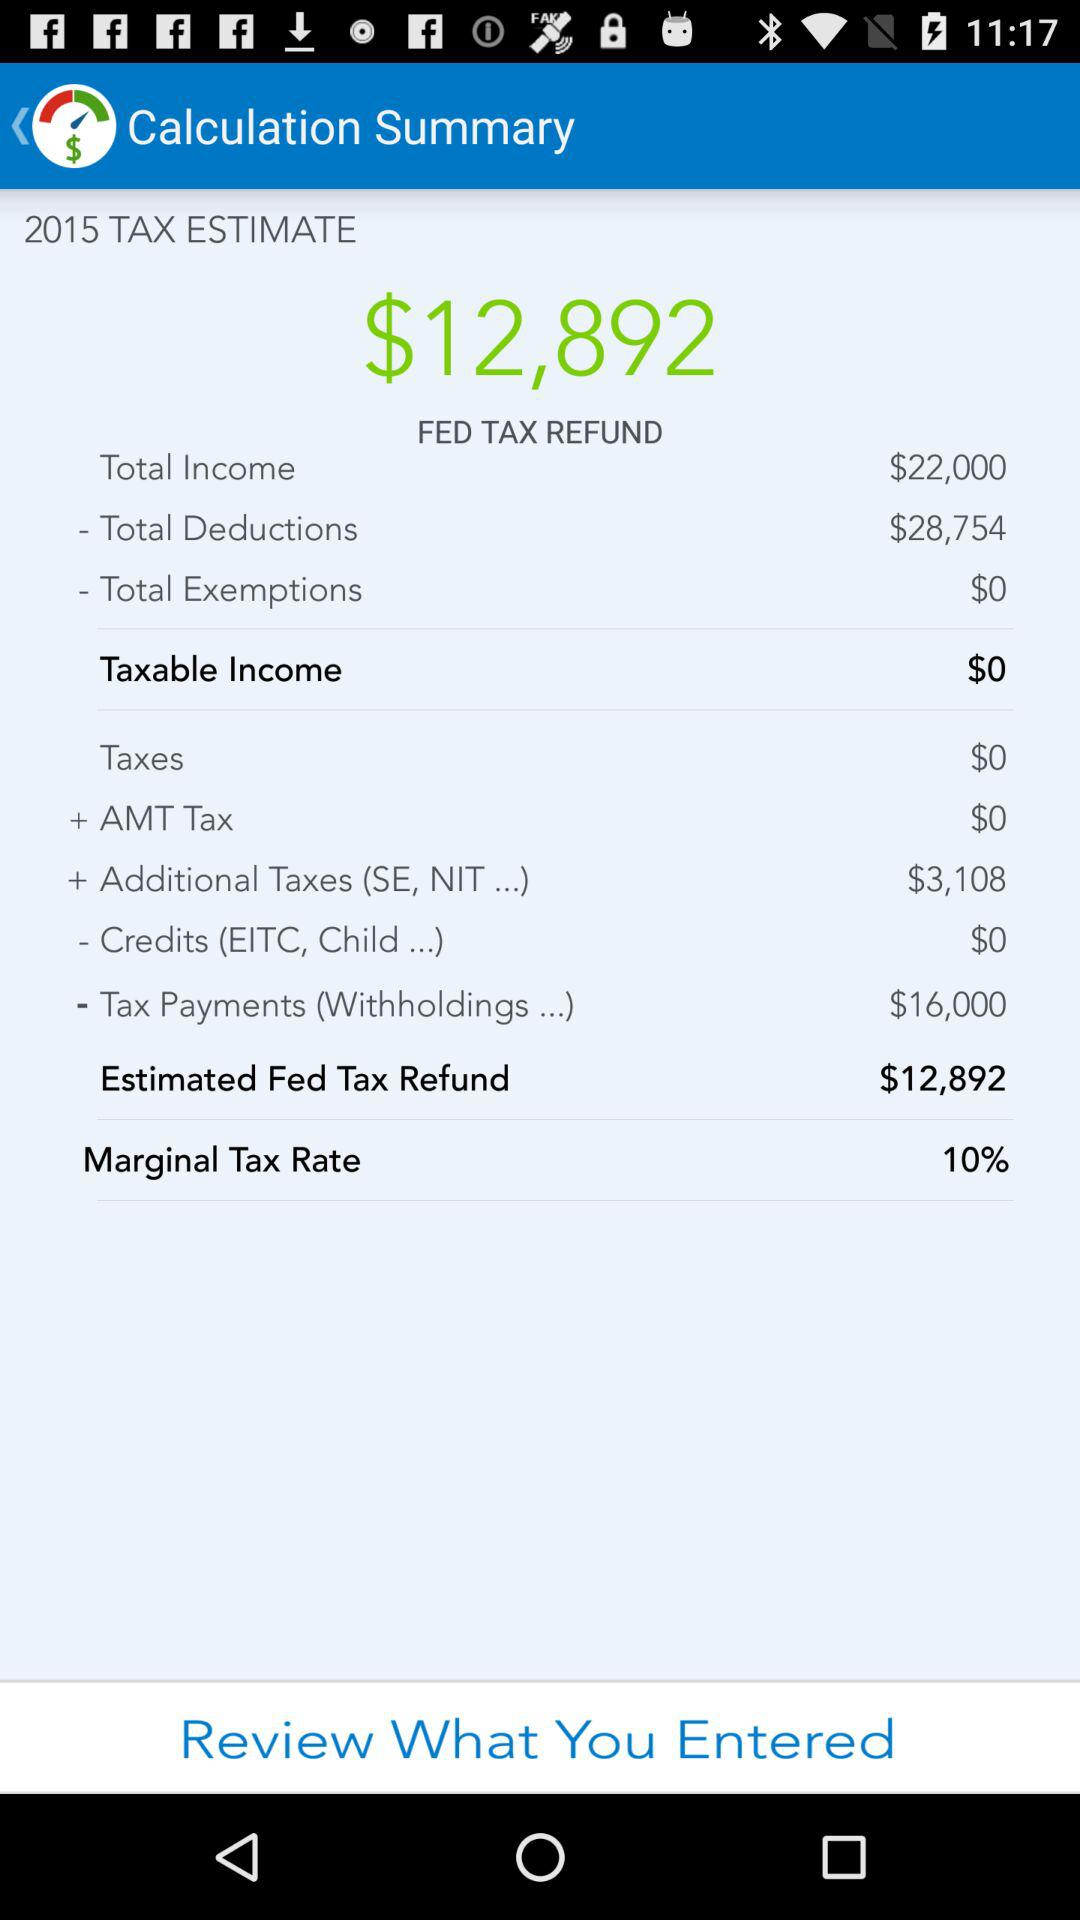What is the difference between the total income and total deductions?
Answer the question using a single word or phrase. $6,754 